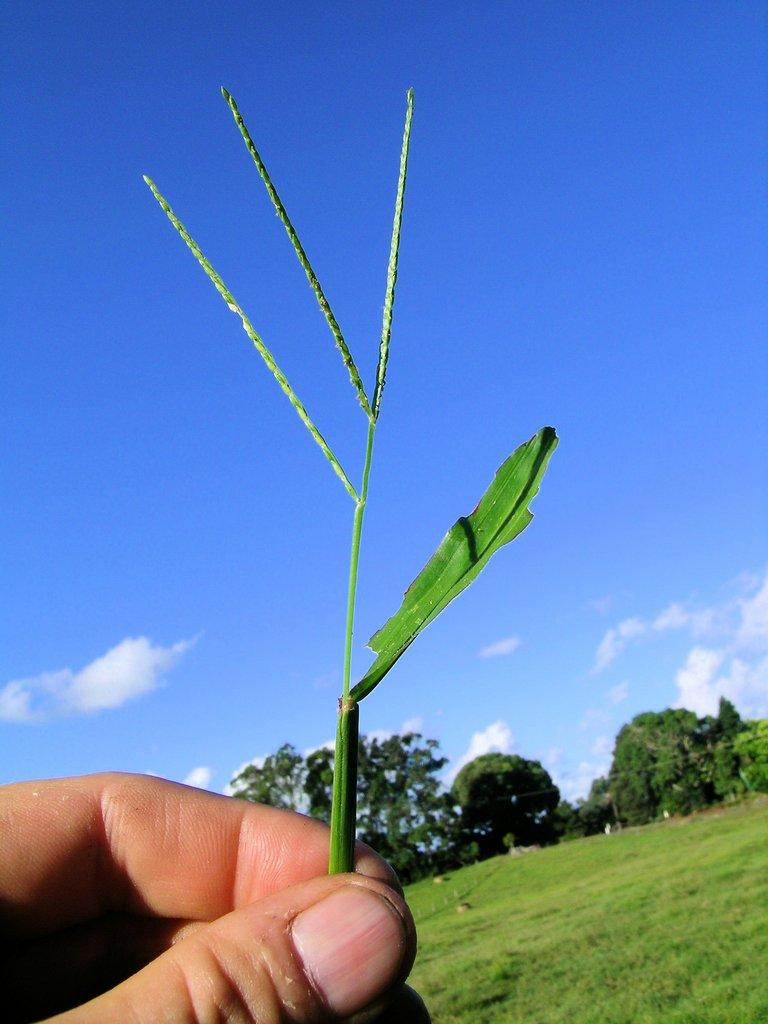What is the person holding in the image? There is a hand of a person holding a plant on the left side of the image. What type of vegetation is visible on the ground in the image? There is grass on the ground on the right side of the image. What can be seen in the background of the image? There are trees and clouds in the sky in the background of the image. What type of crib is visible in the image? There is no crib present in the image. Is the person wearing a glove while holding the plant in the image? The image does not show the person's clothing or accessories, so it cannot be determined if they are wearing a glove. 